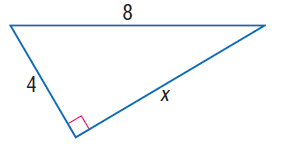Question: Find x.
Choices:
A. 2 \sqrt { 3 }
B. 4 \sqrt { 3 }
C. 4 \sqrt { 5 }
D. 4 \sqrt { 6 }
Answer with the letter. Answer: B 